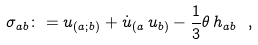<formula> <loc_0><loc_0><loc_500><loc_500>\sigma _ { a b } \colon = u _ { ( a ; b ) } + \dot { u } _ { ( a } \, u _ { b ) } - \frac { 1 } { 3 } \theta \, h _ { a b } \ ,</formula> 